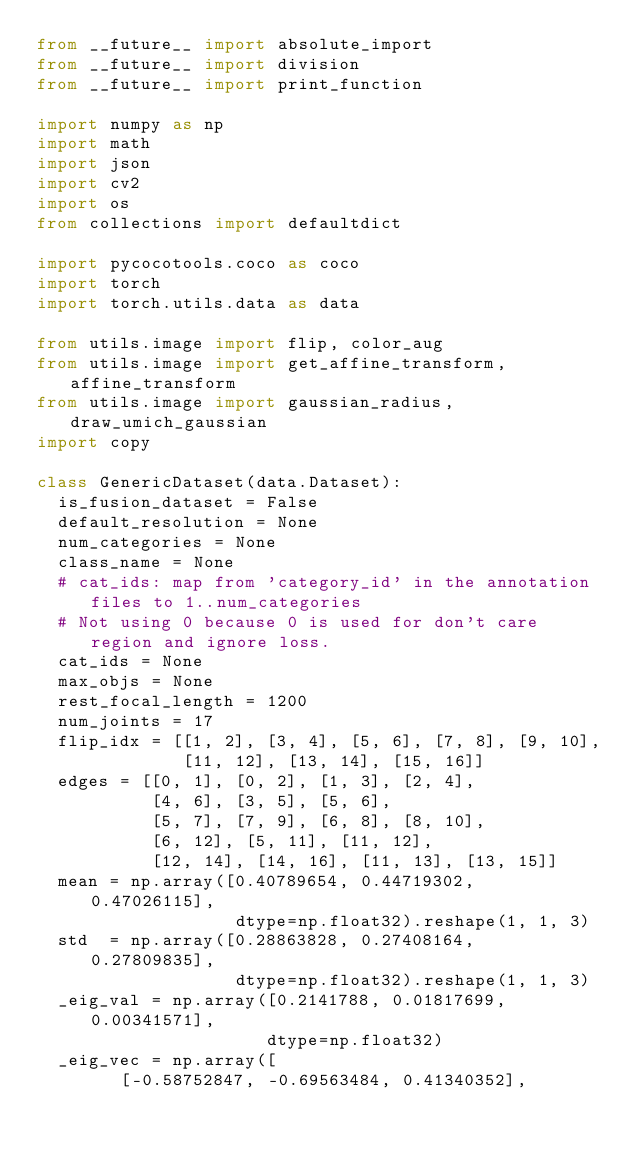Convert code to text. <code><loc_0><loc_0><loc_500><loc_500><_Python_>from __future__ import absolute_import
from __future__ import division
from __future__ import print_function

import numpy as np
import math
import json
import cv2
import os
from collections import defaultdict

import pycocotools.coco as coco
import torch
import torch.utils.data as data

from utils.image import flip, color_aug
from utils.image import get_affine_transform, affine_transform
from utils.image import gaussian_radius, draw_umich_gaussian
import copy

class GenericDataset(data.Dataset):
  is_fusion_dataset = False
  default_resolution = None
  num_categories = None
  class_name = None
  # cat_ids: map from 'category_id' in the annotation files to 1..num_categories
  # Not using 0 because 0 is used for don't care region and ignore loss.
  cat_ids = None
  max_objs = None
  rest_focal_length = 1200
  num_joints = 17
  flip_idx = [[1, 2], [3, 4], [5, 6], [7, 8], [9, 10], 
              [11, 12], [13, 14], [15, 16]]
  edges = [[0, 1], [0, 2], [1, 3], [2, 4], 
           [4, 6], [3, 5], [5, 6], 
           [5, 7], [7, 9], [6, 8], [8, 10], 
           [6, 12], [5, 11], [11, 12], 
           [12, 14], [14, 16], [11, 13], [13, 15]]
  mean = np.array([0.40789654, 0.44719302, 0.47026115],
                   dtype=np.float32).reshape(1, 1, 3)
  std  = np.array([0.28863828, 0.27408164, 0.27809835],
                   dtype=np.float32).reshape(1, 1, 3)
  _eig_val = np.array([0.2141788, 0.01817699, 0.00341571],
                      dtype=np.float32)
  _eig_vec = np.array([
        [-0.58752847, -0.69563484, 0.41340352],</code> 